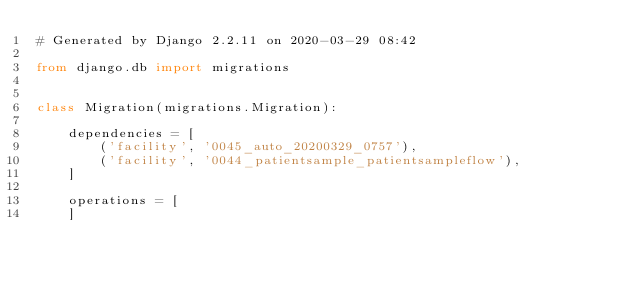Convert code to text. <code><loc_0><loc_0><loc_500><loc_500><_Python_># Generated by Django 2.2.11 on 2020-03-29 08:42

from django.db import migrations


class Migration(migrations.Migration):

    dependencies = [
        ('facility', '0045_auto_20200329_0757'),
        ('facility', '0044_patientsample_patientsampleflow'),
    ]

    operations = [
    ]
</code> 